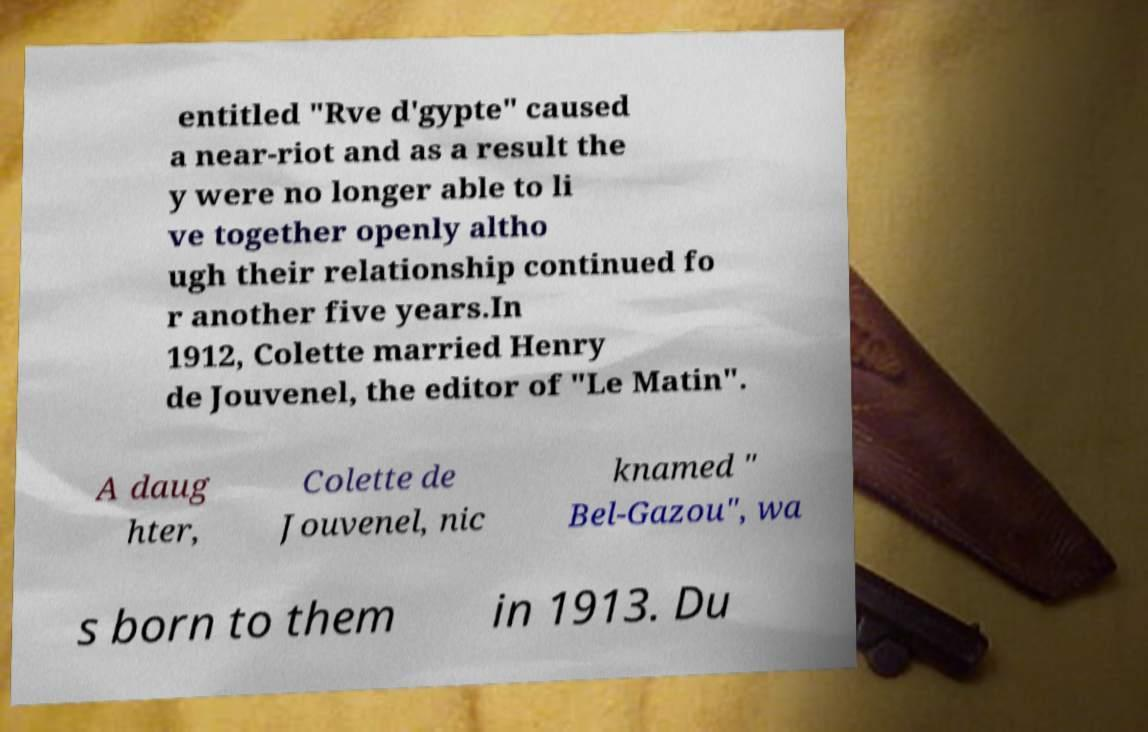I need the written content from this picture converted into text. Can you do that? entitled "Rve d'gypte" caused a near-riot and as a result the y were no longer able to li ve together openly altho ugh their relationship continued fo r another five years.In 1912, Colette married Henry de Jouvenel, the editor of "Le Matin". A daug hter, Colette de Jouvenel, nic knamed " Bel-Gazou", wa s born to them in 1913. Du 